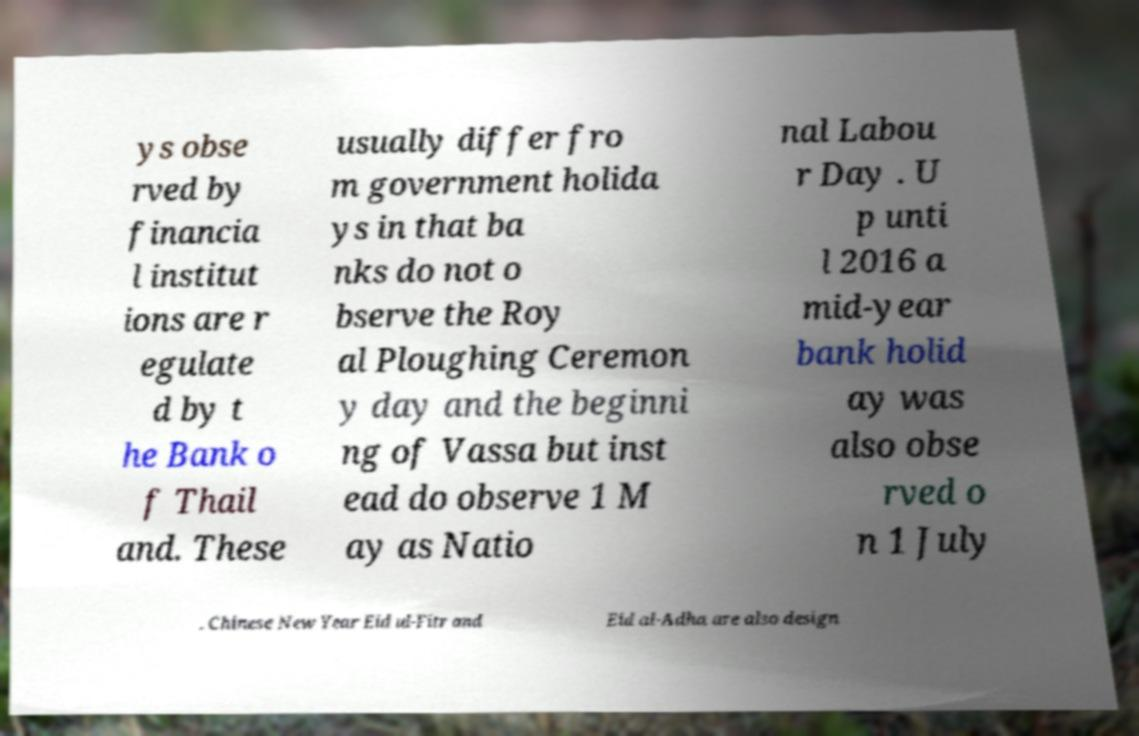Could you assist in decoding the text presented in this image and type it out clearly? ys obse rved by financia l institut ions are r egulate d by t he Bank o f Thail and. These usually differ fro m government holida ys in that ba nks do not o bserve the Roy al Ploughing Ceremon y day and the beginni ng of Vassa but inst ead do observe 1 M ay as Natio nal Labou r Day . U p unti l 2016 a mid-year bank holid ay was also obse rved o n 1 July . Chinese New Year Eid ul-Fitr and Eid al-Adha are also design 